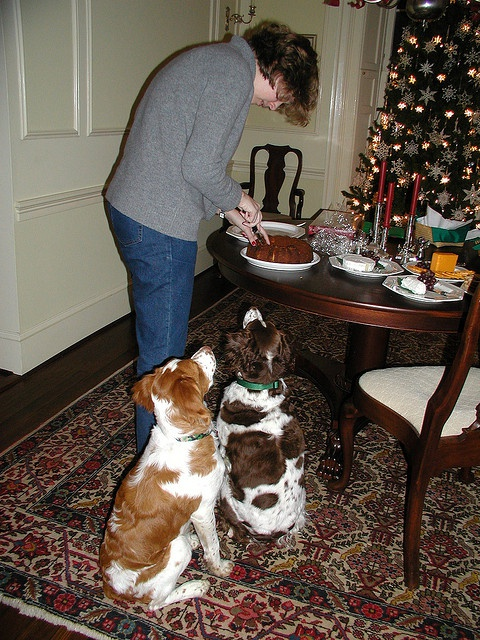Describe the objects in this image and their specific colors. I can see dining table in gray, black, maroon, and darkgray tones, people in gray, black, and navy tones, dog in gray, white, brown, and maroon tones, dog in gray, black, lightgray, maroon, and darkgray tones, and chair in gray, black, darkgray, maroon, and lightgray tones in this image. 